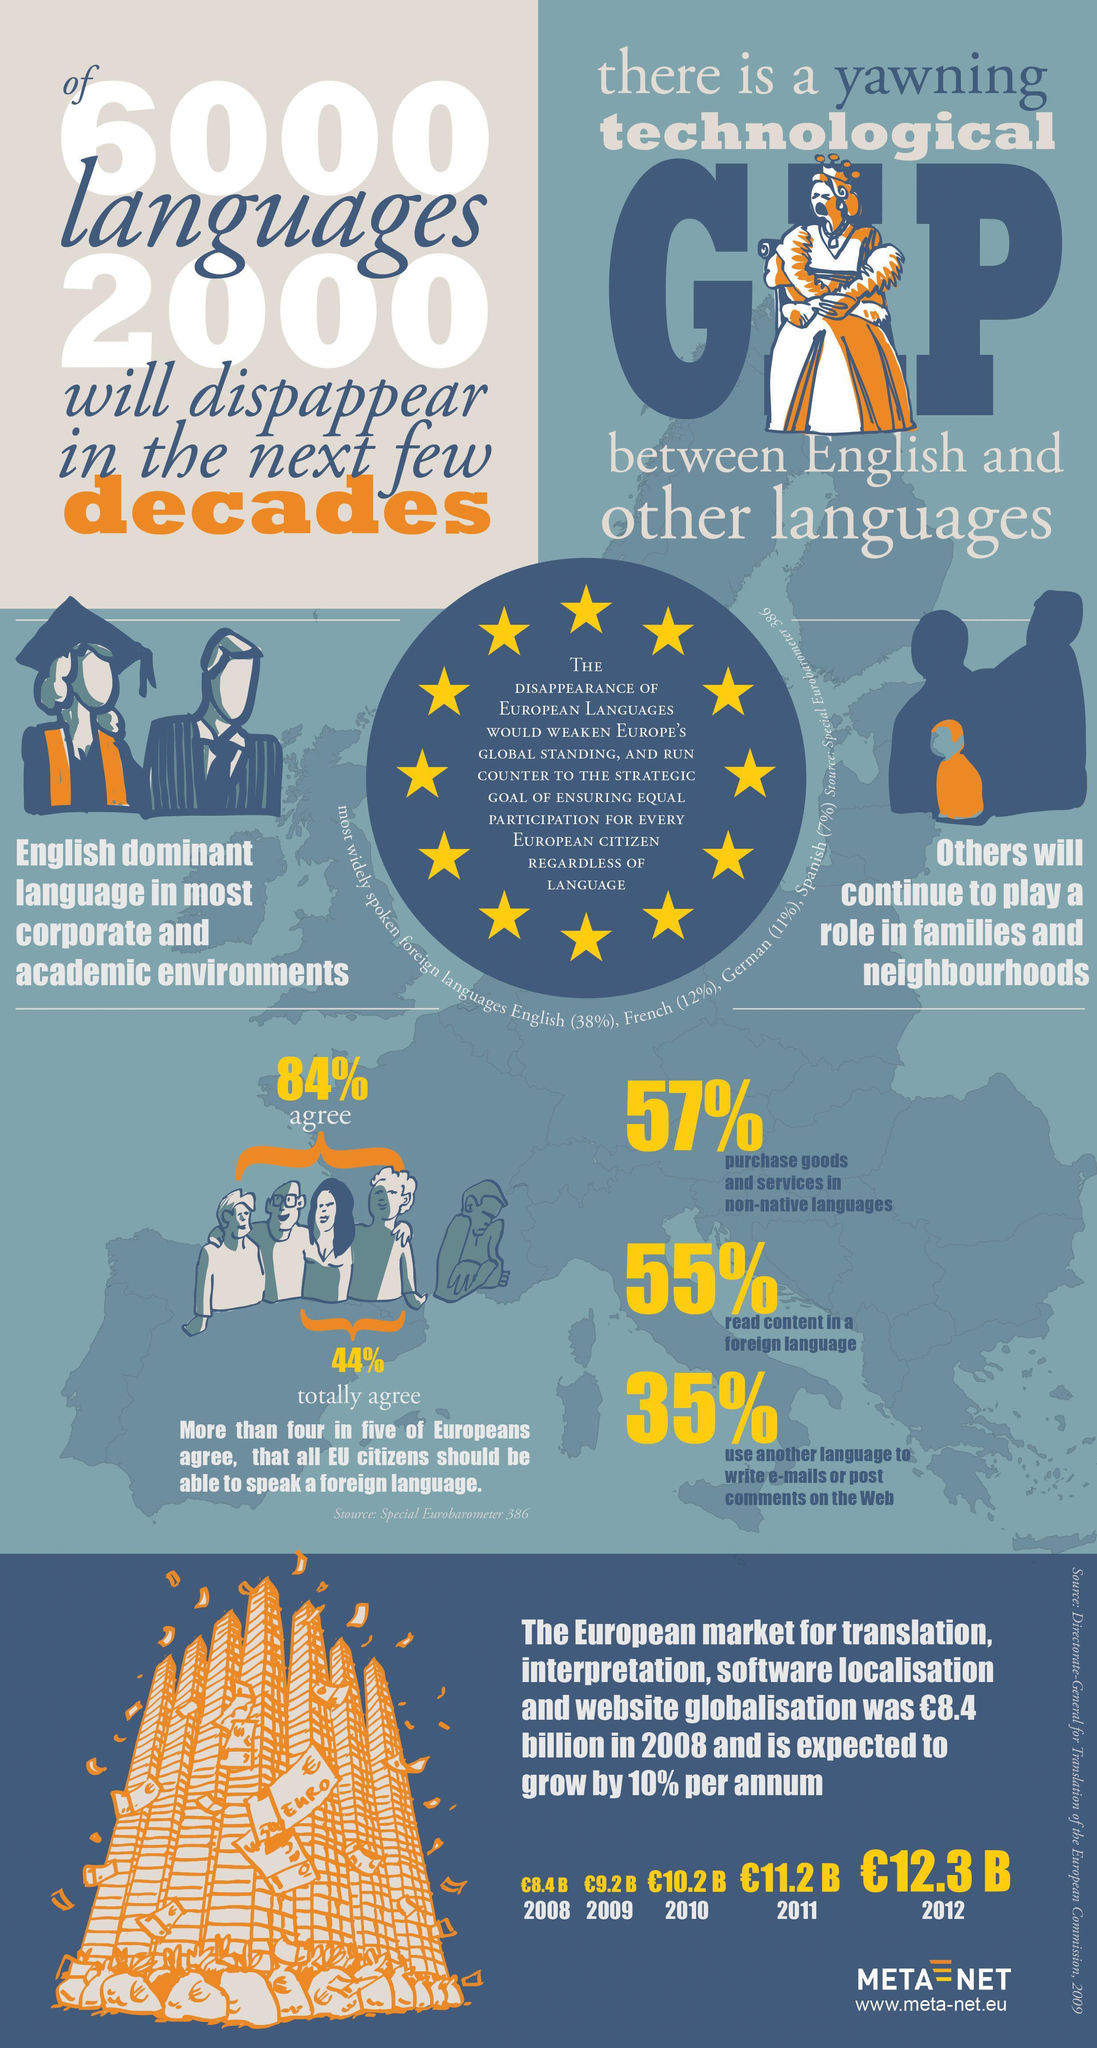what was the European market for translation, interpretation, software localization and website localization in 2011 in Euros?
Answer the question with a short phrase. 11.2B which is second most widely spoken foreign language in Europe? French what was the European market for translation, interpretation, software localization and website localization in 2012 in Euros? 12.3B what was the European  market for translation, interpretation, software localization and website localization in 2010 in Euros? 10.2B what is the increase in European market for translation, interpretation, software localization and website localization from 2011 to 2012 in billion Euros? 1.1 which is third most widely spoken foreign  language in Europe? German 